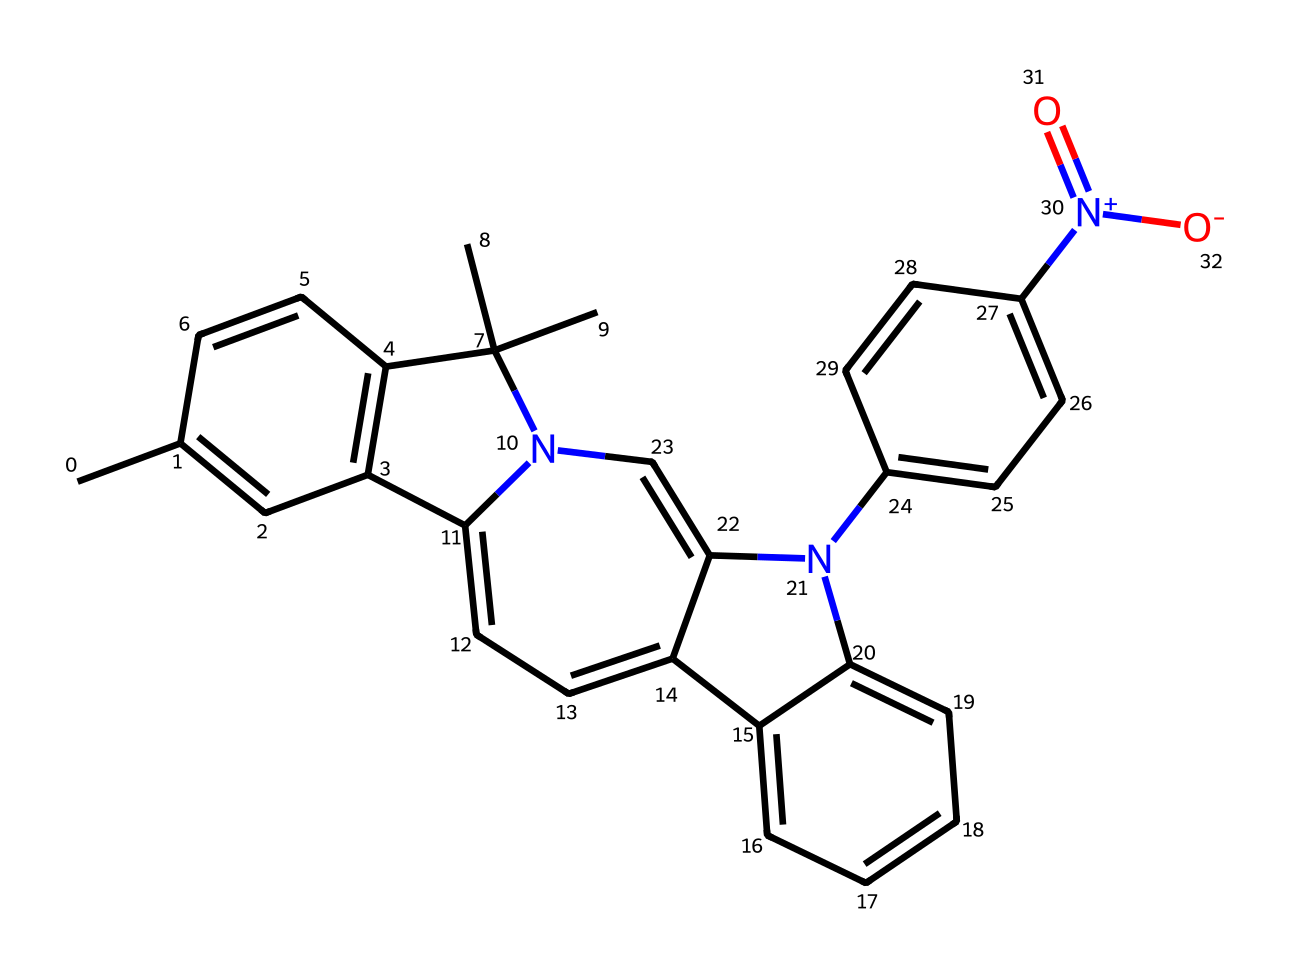What is the molecular formula of this spiropyran compound? By analyzing the SMILES representation, we can identify the types and counts of atoms present in the structure. The formula can be derived by counting the carbon (C), hydrogen (H), nitrogen (N), and oxygen (O) atoms based on the composition provided in the SMILES. There are 20 carbons, 19 hydrogens, 3 nitrogens, and 2 oxygens.
Answer: C20H19N3O2 How many nitrogen atoms are present in this molecule? In the SMILES representation, we can see three instances of nitrogen (N) in the structure. Therefore, by direct counting, we determine the total number of nitrogen atoms in the compound.
Answer: 3 What type of chemical reaction does this spiropyran compound undergo when exposed to UV light? Spiropyran compounds undergo a reversible photoisomerization reaction upon exposure to UV light, converting to a merocyanine form. This process alters the molecular structure in response to light, making it useful for applications in light-activated inks.
Answer: photoisomerization What characteristic does the presence of the quaternary nitrogen indicate? A quaternary nitrogen atom indicates that it is positively charged due to four organic substituents attached to it, which contributes to the electrochemical properties of the spiropyran, enhancing its photoreactivity in response to light.
Answer: positive charge How does the presence of multiple benzene rings affect the stability of the spiropyran compound? The presence of multiple benzene rings introduces resonance stability, which enhances the overall stability of the spiropyran compound. This planarity allows for delocalization of electrons across the rings, making the molecule more robust in chemical environments.
Answer: increased stability What role does the nitro group play in the reactivity of this spiropyran compound? The nitro group is an electron-withdrawing group that can significantly affect the reactivity of the spiropyran. It can facilitate nucleophilic attacks at adjacent sites due to the decreased electron density, influencing how the compound interacts when activated by light.
Answer: increases reactivity 